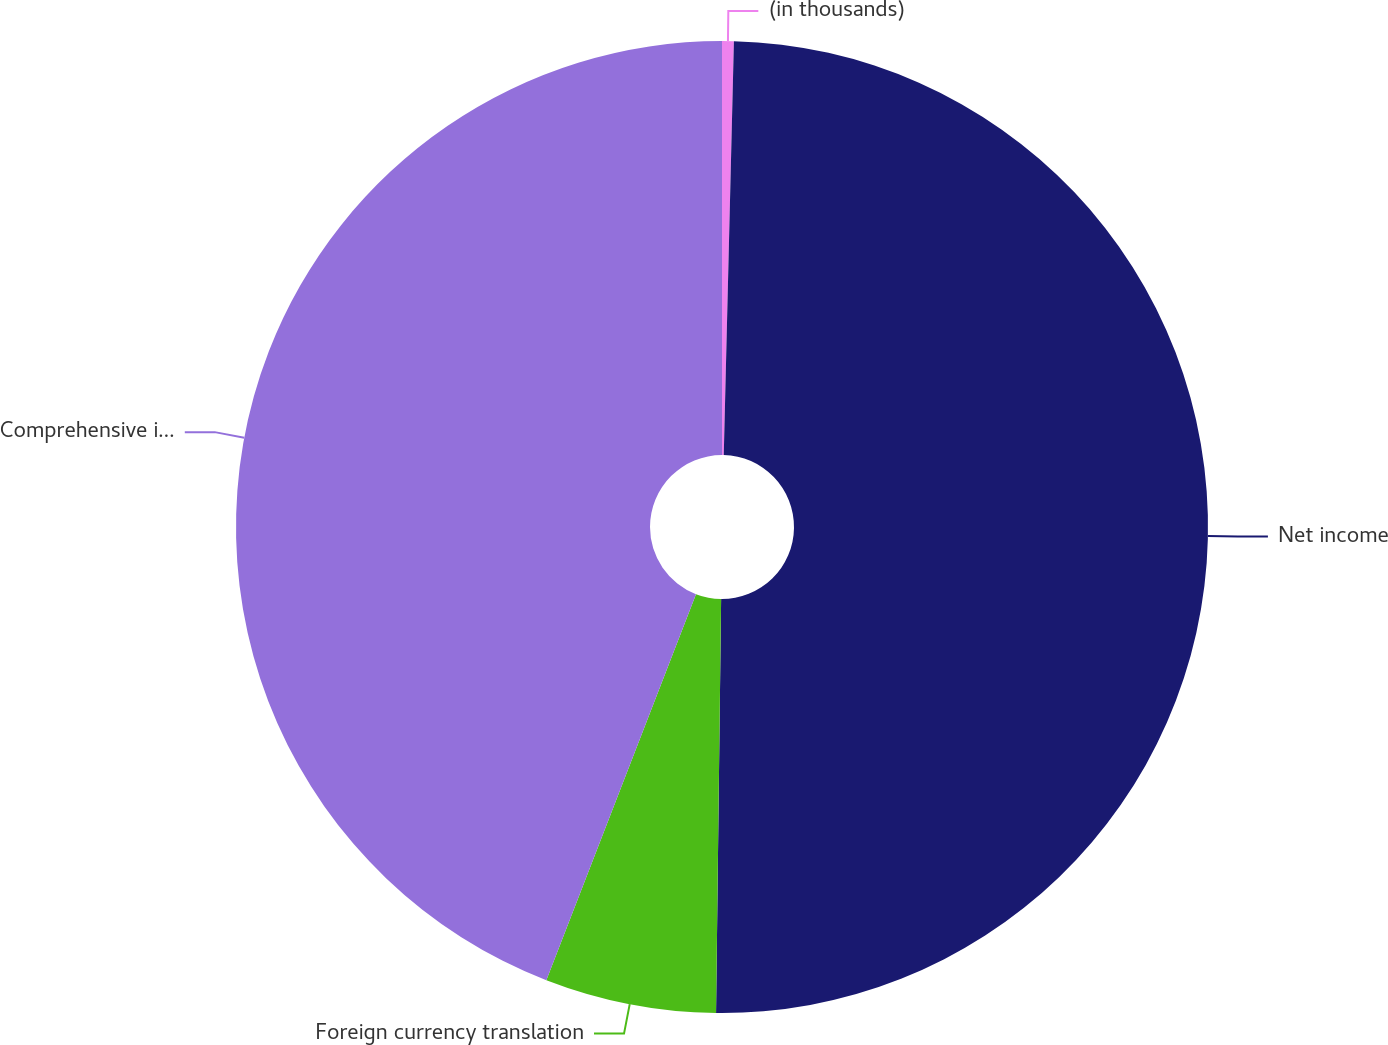Convert chart to OTSL. <chart><loc_0><loc_0><loc_500><loc_500><pie_chart><fcel>(in thousands)<fcel>Net income<fcel>Foreign currency translation<fcel>Comprehensive income<nl><fcel>0.39%<fcel>49.8%<fcel>5.69%<fcel>44.11%<nl></chart> 